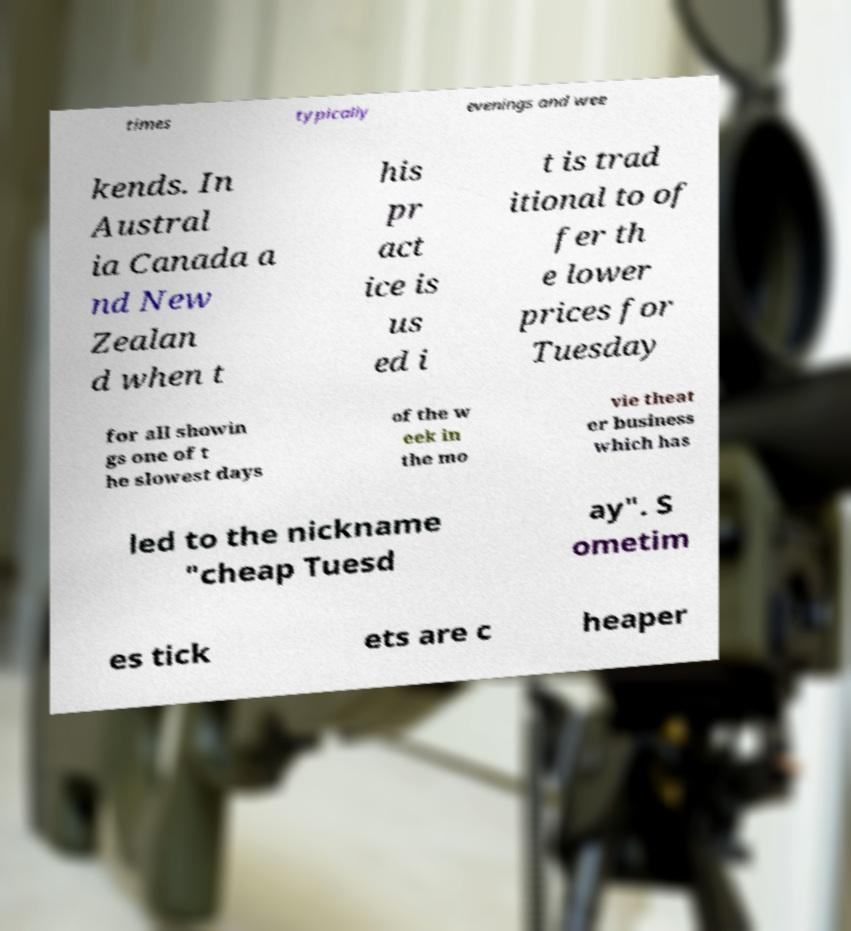What messages or text are displayed in this image? I need them in a readable, typed format. times typically evenings and wee kends. In Austral ia Canada a nd New Zealan d when t his pr act ice is us ed i t is trad itional to of fer th e lower prices for Tuesday for all showin gs one of t he slowest days of the w eek in the mo vie theat er business which has led to the nickname "cheap Tuesd ay". S ometim es tick ets are c heaper 